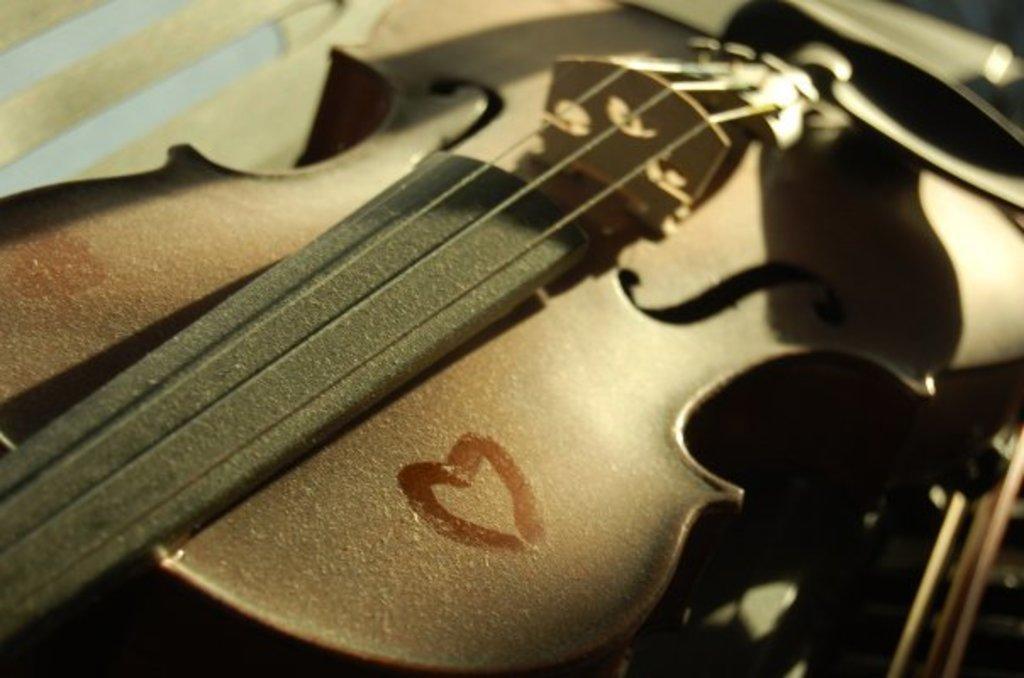Can you describe this image briefly? In this image there is a guitar. 